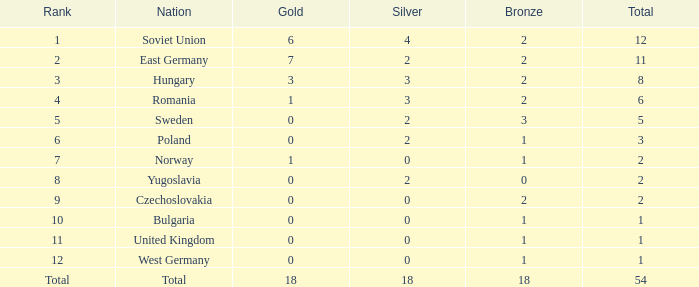What's the highest total of Romania when the bronze was less than 2? None. 